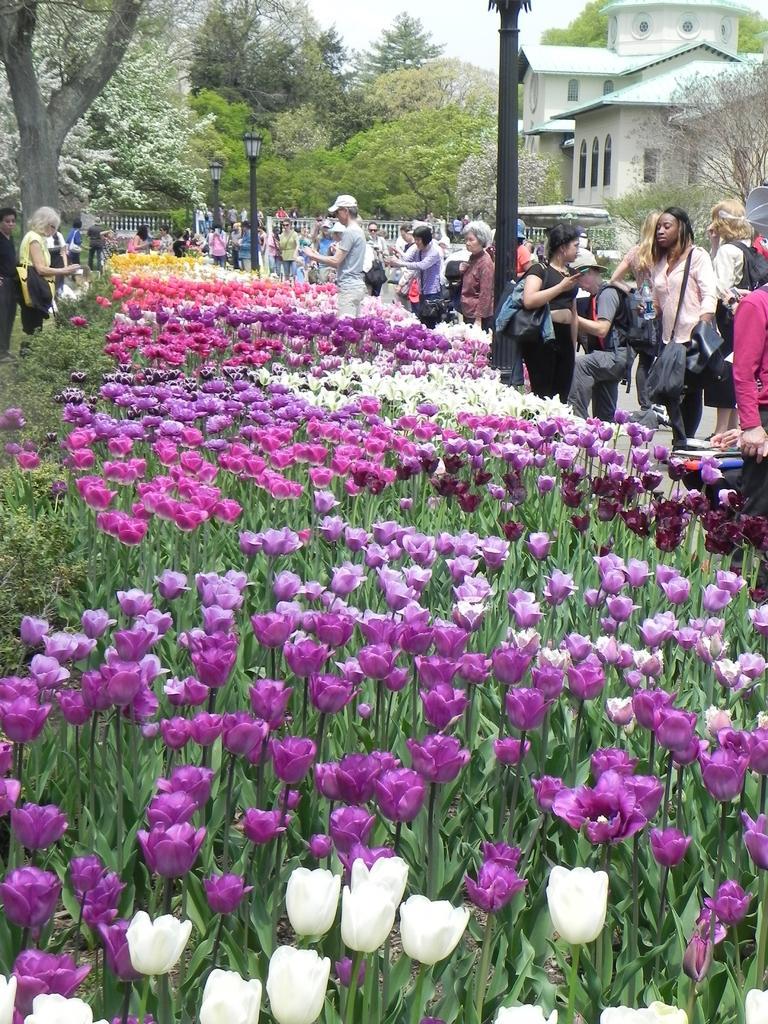Can you describe this image briefly? In this picture I can see there are a few plants and they have different colors of flowers and there are a few people standing on the right side, there is a pole with lights. There are two persons standing on the left side and there is a building on the right side, there are few trees. 